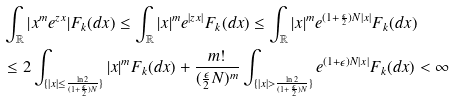<formula> <loc_0><loc_0><loc_500><loc_500>& \int _ { \mathbb { R } } | x ^ { m } e ^ { z x } | F _ { k } ( d x ) \leq \int _ { \mathbb { R } } | x | ^ { m } e ^ { | z x | } F _ { k } ( d x ) \leq \int _ { \mathbb { R } } | x | ^ { m } e ^ { ( 1 + \frac { \epsilon } { 2 } ) N | x | } F _ { k } ( d x ) \\ & \leq 2 \int _ { \{ | x | \leq \frac { \ln 2 } { ( 1 + \frac { \epsilon } { 2 } ) N } \} } | x | ^ { m } F _ { k } ( d x ) + \frac { m ! } { ( \frac { \epsilon } { 2 } N ) ^ { m } } \int _ { \{ | x | > \frac { \ln 2 } { ( 1 + \frac { \epsilon } { 2 } ) N } \} } e ^ { ( 1 + \epsilon ) N | x | } F _ { k } ( d x ) < \infty</formula> 